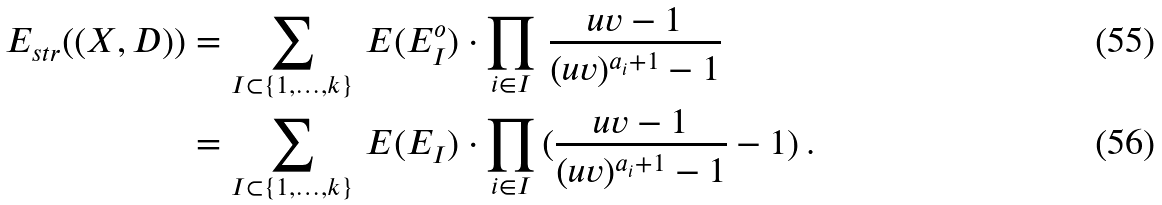<formula> <loc_0><loc_0><loc_500><loc_500>E _ { s t r } ( ( X , D ) ) & = \sum _ { I \subset \{ 1 , \dots , k \} } \, E ( E _ { I } ^ { o } ) \cdot \prod _ { i \in I } \, \frac { u v - 1 } { ( u v ) ^ { a _ { i } + 1 } - 1 } \\ & = \sum _ { I \subset \{ 1 , \dots , k \} } \, E ( E _ { I } ) \cdot \prod _ { i \in I } \, ( \frac { u v - 1 } { ( u v ) ^ { a _ { i } + 1 } - 1 } - 1 ) \, .</formula> 